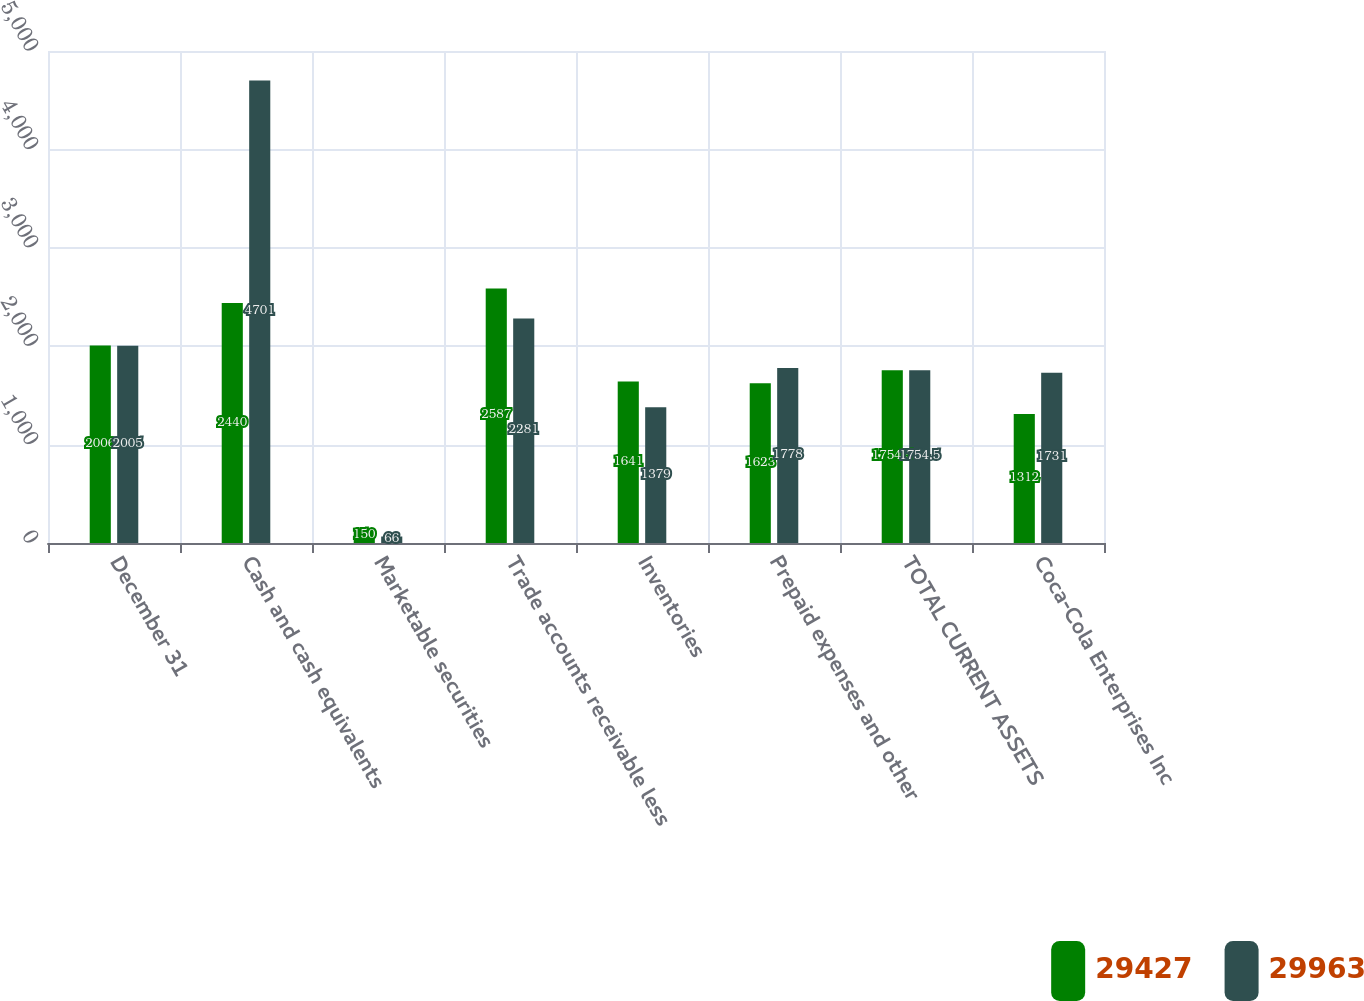Convert chart to OTSL. <chart><loc_0><loc_0><loc_500><loc_500><stacked_bar_chart><ecel><fcel>December 31<fcel>Cash and cash equivalents<fcel>Marketable securities<fcel>Trade accounts receivable less<fcel>Inventories<fcel>Prepaid expenses and other<fcel>TOTAL CURRENT ASSETS<fcel>Coca-Cola Enterprises Inc<nl><fcel>29427<fcel>2006<fcel>2440<fcel>150<fcel>2587<fcel>1641<fcel>1623<fcel>1754.5<fcel>1312<nl><fcel>29963<fcel>2005<fcel>4701<fcel>66<fcel>2281<fcel>1379<fcel>1778<fcel>1754.5<fcel>1731<nl></chart> 